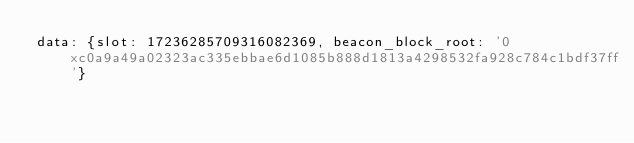<code> <loc_0><loc_0><loc_500><loc_500><_YAML_>data: {slot: 17236285709316082369, beacon_block_root: '0xc0a9a49a02323ac335ebbae6d1085b888d1813a4298532fa928c784c1bdf37ff'}</code> 